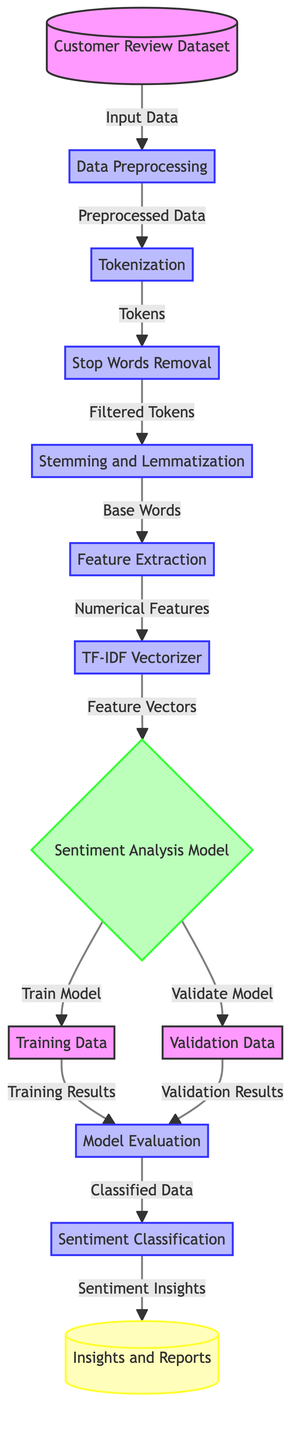What is the first step after receiving the customer review dataset? The first step is "Data Preprocessing," which immediately follows the input of the dataset in the diagram.
Answer: Data Preprocessing How many main processes are there in the diagram? By counting the labeled process nodes, there are a total of six main processes in the diagram connecting the flow from data preprocessing to model evaluation.
Answer: Six What type of model is used for analyzing sentiment? The node labeled "Sentiment Analysis Model" indicates that a specific model type is adopted for the analysis of customer sentiments.
Answer: Sentiment Analysis Model Which process follows "Feature Extraction"? After "Feature Extraction," the next process illustrated in the diagram is "TF-IDF Vectorizer," showing the sequential flow of operations involved in analyzing sentiment.
Answer: TF-IDF Vectorizer How does the model evaluation process utilize both training and validation data? The diagram shows that the "Model Evaluation" node receives input from both "Training Data" and "Validation Data," indicating that both datasets are essential for evaluating the model's performance.
Answer: Both Training Data and Validation Data What is the output of the "Sentiment Classification" process? The output of the "Sentiment Classification" process directly leads to "Sentiment Insights and Reports," indicating the final deliverables from the classification task.
Answer: Sentiment Insights and Reports Which process occurs immediately after "Training Data"? The process labeled as "Model Evaluation" occurs immediately after "Training Data," establishing a clear progression from training results to evaluation metrics in the diagram.
Answer: Model Evaluation What are the two results obtained from the evaluation process? The outcomes of the evaluation process are denoted as "Training Results" and "Validation Results," showing that both results are obtained concurrently during model assessment.
Answer: Training Results and Validation Results How many preprocessing steps are listed before feature extraction? There are three distinct preprocessing steps listed before reaching "Feature Extraction," which include "Tokenization," "Stop Words Removal," and "Stemming and Lemmatization."
Answer: Three 